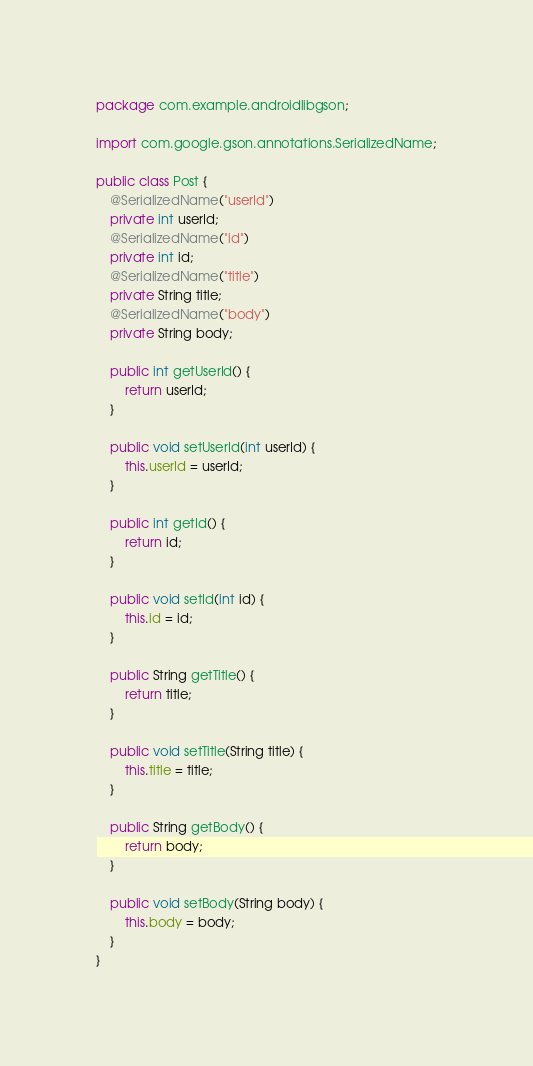<code> <loc_0><loc_0><loc_500><loc_500><_Java_>package com.example.androidlibgson;

import com.google.gson.annotations.SerializedName;

public class Post {
    @SerializedName("userId")
    private int userId;
    @SerializedName("id")
    private int id;
    @SerializedName("title")
    private String title;
    @SerializedName("body")
    private String body;

    public int getUserId() {
        return userId;
    }

    public void setUserId(int userId) {
        this.userId = userId;
    }

    public int getId() {
        return id;
    }

    public void setId(int id) {
        this.id = id;
    }

    public String getTitle() {
        return title;
    }

    public void setTitle(String title) {
        this.title = title;
    }

    public String getBody() {
        return body;
    }

    public void setBody(String body) {
        this.body = body;
    }
}
</code> 